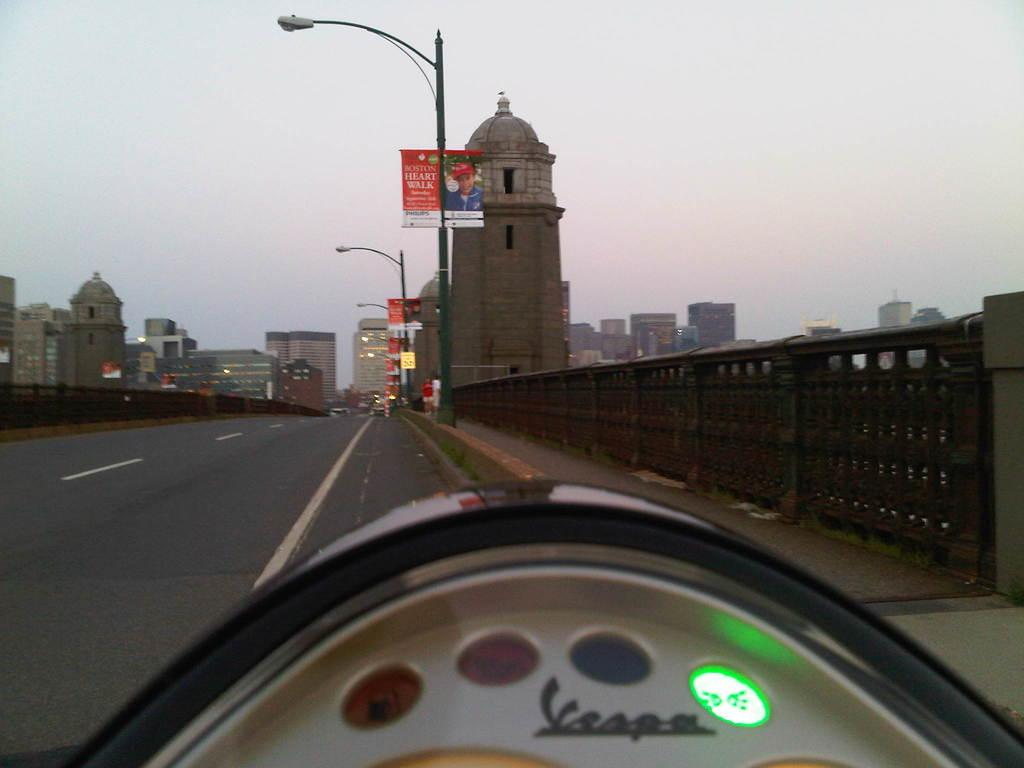What type of structures can be seen in the image? There are buildings in the image. What type of lighting is present along the road in the image? Street lights are present in the image. What type of barrier is visible in the image? There is a fence in the image. What type of pathway is visible in the image? A road is visible in the image. What can be seen in the background of the image? The sky is visible in the background of the image. What type of signage is present in the image? There are banners on poles in the image. Can you tell me how many pies the pig is holding in the image? There is no pig or pies present in the image. How high can the pig jump in the image? There is no pig present in the image, so it cannot jump. 